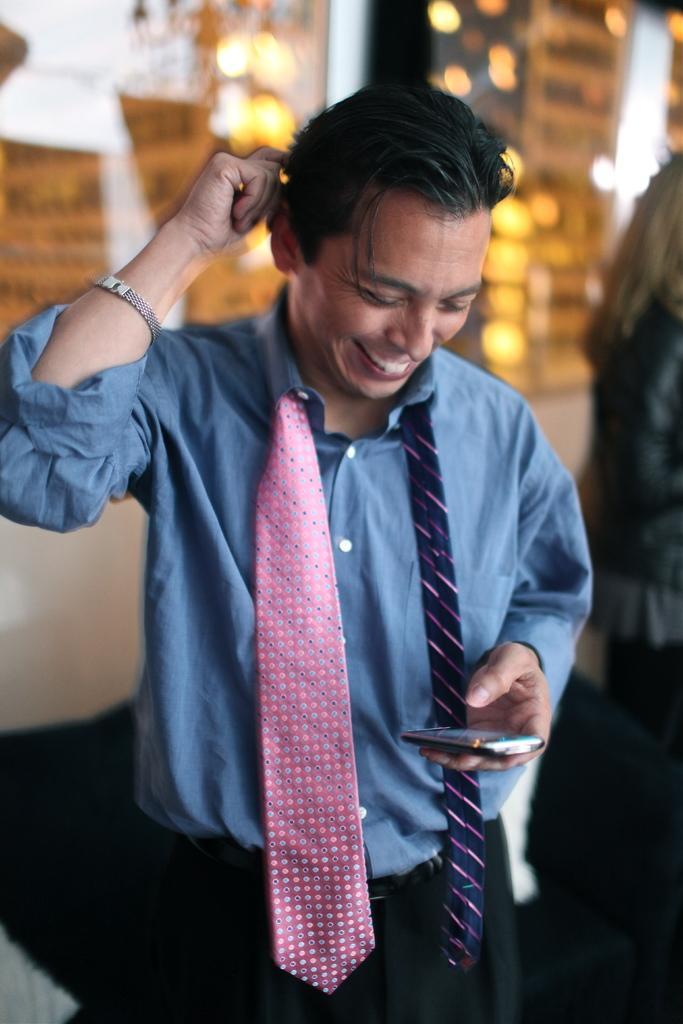How would you summarize this image in a sentence or two? In this image we can see a man holding the mobile phone and standing and also smiling. In the background, we can see a woman on the right and we can also see the lights and some part of the background is unclear and blurred. 